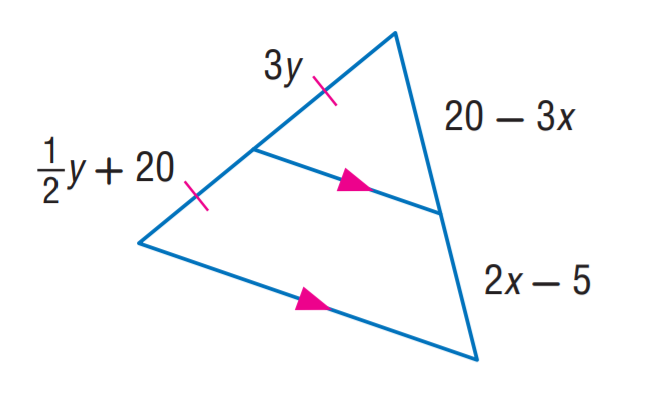Answer the mathemtical geometry problem and directly provide the correct option letter.
Question: Find y.
Choices: A: 6 B: 8 C: 10 D: 20 B 